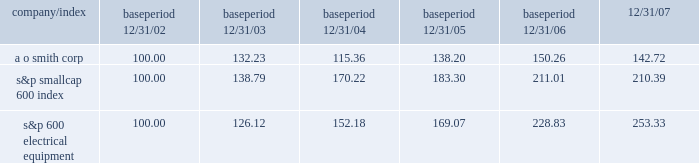The graph below shows a five-year comparison of the cumulative shareholder return on the company's common stock with the cumulative total return of the s&p smallcap 600 index and the s&p 600 electrical equipment index , all of which are published indices .
Comparison of five-year cumulative total return from december 31 , 2002 to december 31 , 2007 assumes $ 100 invested with reinvestment of dividends period indexed returns .
12/31/02 12/31/03 12/31/04 12/31/05 12/31/06 12/31/07 smith ( a o ) corp s&p smallcap 600 index s&p 600 electrical equipment .
What was the difference in cumulative total return for the five year period ending 12/31/07 between a o smith corp and the s&p smallcap 600 index? 
Computations: (((142.72 - 100) / 100) - ((210.39 - 100) / 100))
Answer: -0.6767. The graph below shows a five-year comparison of the cumulative shareholder return on the company's common stock with the cumulative total return of the s&p smallcap 600 index and the s&p 600 electrical equipment index , all of which are published indices .
Comparison of five-year cumulative total return from december 31 , 2002 to december 31 , 2007 assumes $ 100 invested with reinvestment of dividends period indexed returns .
12/31/02 12/31/03 12/31/04 12/31/05 12/31/06 12/31/07 smith ( a o ) corp s&p smallcap 600 index s&p 600 electrical equipment .
What was the difference in cumulative total return for the five year period ending 12/31/07 between a o smith corp and the s&p 600 electrical equipment? 
Computations: (((142.72 - 100) / 100) - ((253.33 - 100) / 100))
Answer: -1.1061. 